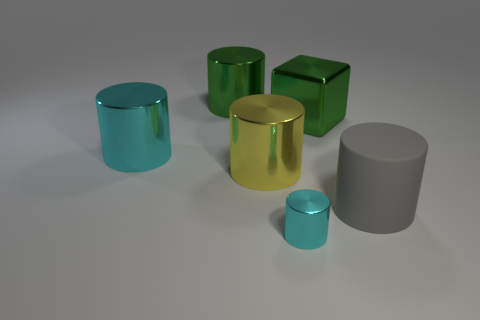Can you describe the textures and materials represented? Certainly, the objects display a variety of textures and materials. The cyan and green cylinders exhibit a smooth, reflective metal finish, providing a sleek and modern look. In contrast, the grey cylinder appears to have a matte surface, which absorbs rather than reflects the light, suggesting a non-metallic, possibly ceramic or plastic composition. Each material interacts uniquely with light, allowing for a rich interplay of luster and sheen.  What might be the purpose of this arrangement? This arrangement seems to serve as an artistic display or a visual study of geometric forms and their interaction with light and color. The deliberate positioning and choice of materials could be meant to evoke a contemplative mood, invite aesthetic appreciation, or showcase design elements in a minimalist setting. It might also be an illustration for educational purposes, explaining concepts of shading, perspective, and color theory. 